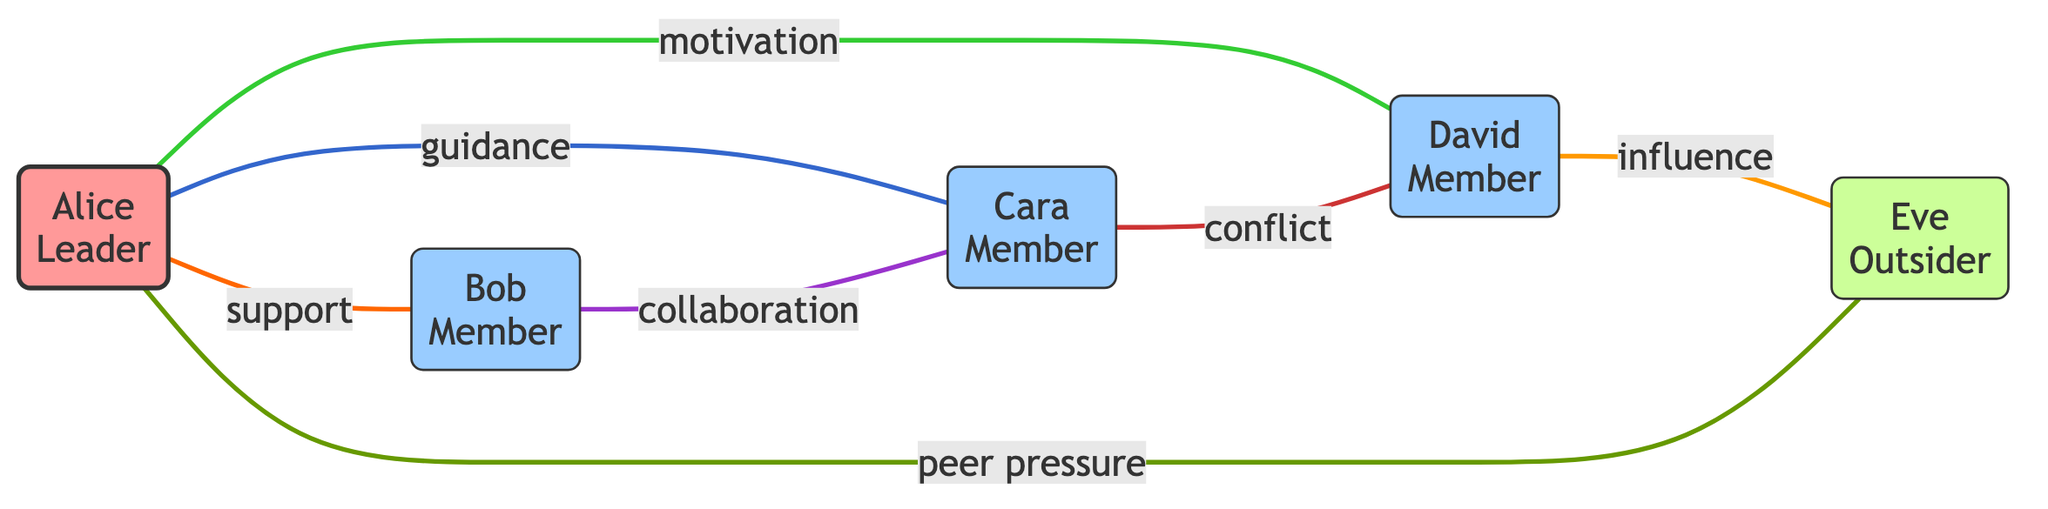What is the role of Alice? Alice is labeled as the "Leader" in the diagram, indicated by her node.
Answer: Leader How many members are there in the group? The nodes representing group members are Bob, Cara, and David, making a total of 3 members.
Answer: 3 What type of interaction exists between Alice and Bob? The diagram shows an edge labeled "support" connecting Alice and Bob, indicating their interaction type.
Answer: support Who does David have a conflict with? The edge between Cara and David is labeled "conflict," indicating their relationship.
Answer: Cara Which node represents an outsider? The node labeled "Eve" has the role of "Outsider," as shown in the diagram.
Answer: Eve What interaction does Eve have with Alice? The interaction labeled "peer pressure" connects Eve to Alice, indicating the nature of their relationship.
Answer: peer pressure How does David influence Eve? The edge connecting David to Eve is labeled "influence," showing how David impacts Eve's behavior.
Answer: influence What are the roles of Bob and Cara? Bob is labeled as a "Member," and Cara is also identified as a "Member" in the diagram.
Answer: Member How many interactions are shown in the diagram? The diagram has a total of 7 interactions (edges) between the nodes.
Answer: 7 What is the nature of interaction between Bob and Cara? The interaction labeled "collaboration" connects Bob and Cara, explaining their relationship.
Answer: collaboration 